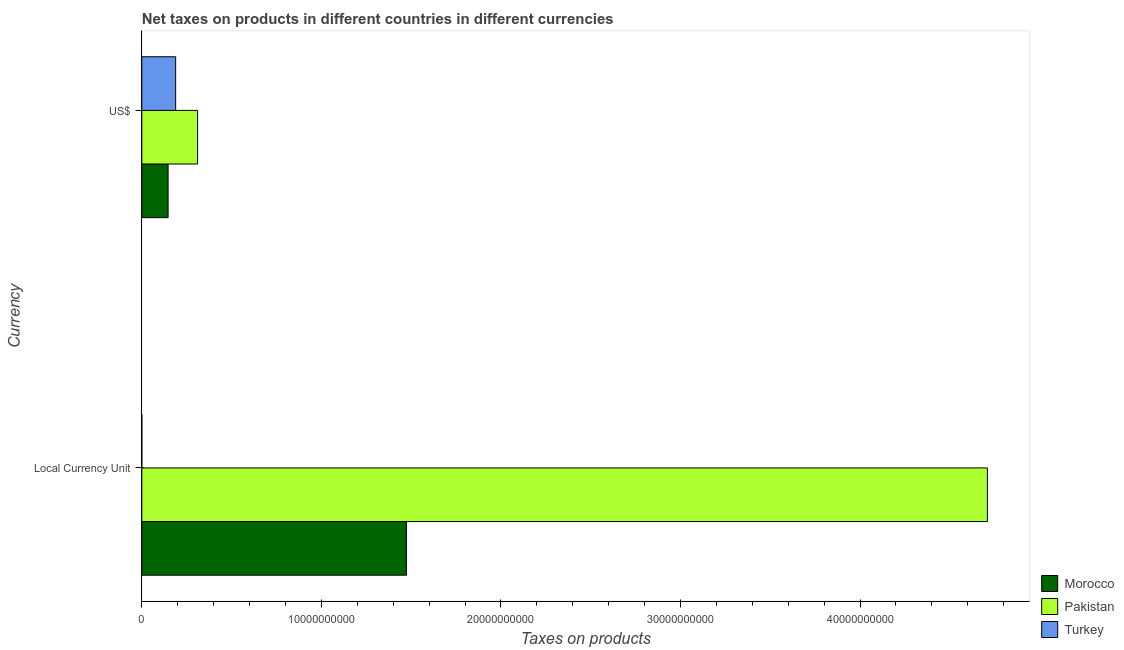How many different coloured bars are there?
Your answer should be compact. 3. How many groups of bars are there?
Make the answer very short. 2. Are the number of bars per tick equal to the number of legend labels?
Your answer should be compact. Yes. Are the number of bars on each tick of the Y-axis equal?
Keep it short and to the point. Yes. What is the label of the 2nd group of bars from the top?
Offer a terse response. Local Currency Unit. What is the net taxes in constant 2005 us$ in Pakistan?
Provide a short and direct response. 4.71e+1. Across all countries, what is the maximum net taxes in us$?
Give a very brief answer. 3.11e+09. Across all countries, what is the minimum net taxes in constant 2005 us$?
Offer a terse response. 9.84e+05. In which country was the net taxes in us$ maximum?
Your answer should be compact. Pakistan. In which country was the net taxes in us$ minimum?
Offer a very short reply. Morocco. What is the total net taxes in constant 2005 us$ in the graph?
Provide a succinct answer. 6.18e+1. What is the difference between the net taxes in us$ in Morocco and that in Pakistan?
Keep it short and to the point. -1.64e+09. What is the difference between the net taxes in us$ in Turkey and the net taxes in constant 2005 us$ in Pakistan?
Offer a terse response. -4.52e+1. What is the average net taxes in constant 2005 us$ per country?
Your answer should be very brief. 2.06e+1. What is the difference between the net taxes in us$ and net taxes in constant 2005 us$ in Morocco?
Your answer should be very brief. -1.33e+1. In how many countries, is the net taxes in constant 2005 us$ greater than 14000000000 units?
Make the answer very short. 2. What is the ratio of the net taxes in us$ in Turkey to that in Pakistan?
Provide a short and direct response. 0.61. Is the net taxes in constant 2005 us$ in Turkey less than that in Morocco?
Provide a succinct answer. Yes. In how many countries, is the net taxes in constant 2005 us$ greater than the average net taxes in constant 2005 us$ taken over all countries?
Your answer should be very brief. 1. What does the 3rd bar from the top in Local Currency Unit represents?
Your response must be concise. Morocco. How many countries are there in the graph?
Your answer should be very brief. 3. Are the values on the major ticks of X-axis written in scientific E-notation?
Your response must be concise. No. Does the graph contain grids?
Keep it short and to the point. No. Where does the legend appear in the graph?
Ensure brevity in your answer.  Bottom right. How are the legend labels stacked?
Offer a terse response. Vertical. What is the title of the graph?
Give a very brief answer. Net taxes on products in different countries in different currencies. Does "Honduras" appear as one of the legend labels in the graph?
Keep it short and to the point. No. What is the label or title of the X-axis?
Keep it short and to the point. Taxes on products. What is the label or title of the Y-axis?
Keep it short and to the point. Currency. What is the Taxes on products in Morocco in Local Currency Unit?
Keep it short and to the point. 1.47e+1. What is the Taxes on products of Pakistan in Local Currency Unit?
Offer a very short reply. 4.71e+1. What is the Taxes on products in Turkey in Local Currency Unit?
Your response must be concise. 9.84e+05. What is the Taxes on products of Morocco in US$?
Ensure brevity in your answer.  1.46e+09. What is the Taxes on products in Pakistan in US$?
Give a very brief answer. 3.11e+09. What is the Taxes on products in Turkey in US$?
Ensure brevity in your answer.  1.89e+09. Across all Currency, what is the maximum Taxes on products of Morocco?
Your answer should be very brief. 1.47e+1. Across all Currency, what is the maximum Taxes on products in Pakistan?
Keep it short and to the point. 4.71e+1. Across all Currency, what is the maximum Taxes on products of Turkey?
Make the answer very short. 1.89e+09. Across all Currency, what is the minimum Taxes on products in Morocco?
Ensure brevity in your answer.  1.46e+09. Across all Currency, what is the minimum Taxes on products of Pakistan?
Keep it short and to the point. 3.11e+09. Across all Currency, what is the minimum Taxes on products in Turkey?
Give a very brief answer. 9.84e+05. What is the total Taxes on products in Morocco in the graph?
Offer a very short reply. 1.62e+1. What is the total Taxes on products of Pakistan in the graph?
Your answer should be compact. 5.02e+1. What is the total Taxes on products in Turkey in the graph?
Provide a succinct answer. 1.89e+09. What is the difference between the Taxes on products in Morocco in Local Currency Unit and that in US$?
Provide a short and direct response. 1.33e+1. What is the difference between the Taxes on products in Pakistan in Local Currency Unit and that in US$?
Keep it short and to the point. 4.40e+1. What is the difference between the Taxes on products of Turkey in Local Currency Unit and that in US$?
Your answer should be very brief. -1.88e+09. What is the difference between the Taxes on products in Morocco in Local Currency Unit and the Taxes on products in Pakistan in US$?
Your answer should be compact. 1.16e+1. What is the difference between the Taxes on products in Morocco in Local Currency Unit and the Taxes on products in Turkey in US$?
Provide a succinct answer. 1.29e+1. What is the difference between the Taxes on products of Pakistan in Local Currency Unit and the Taxes on products of Turkey in US$?
Your answer should be compact. 4.52e+1. What is the average Taxes on products of Morocco per Currency?
Your answer should be compact. 8.10e+09. What is the average Taxes on products in Pakistan per Currency?
Ensure brevity in your answer.  2.51e+1. What is the average Taxes on products of Turkey per Currency?
Give a very brief answer. 9.43e+08. What is the difference between the Taxes on products in Morocco and Taxes on products in Pakistan in Local Currency Unit?
Offer a terse response. -3.24e+1. What is the difference between the Taxes on products in Morocco and Taxes on products in Turkey in Local Currency Unit?
Keep it short and to the point. 1.47e+1. What is the difference between the Taxes on products of Pakistan and Taxes on products of Turkey in Local Currency Unit?
Keep it short and to the point. 4.71e+1. What is the difference between the Taxes on products of Morocco and Taxes on products of Pakistan in US$?
Offer a terse response. -1.64e+09. What is the difference between the Taxes on products of Morocco and Taxes on products of Turkey in US$?
Your answer should be very brief. -4.22e+08. What is the difference between the Taxes on products of Pakistan and Taxes on products of Turkey in US$?
Your answer should be very brief. 1.22e+09. What is the ratio of the Taxes on products in Morocco in Local Currency Unit to that in US$?
Give a very brief answer. 10.06. What is the ratio of the Taxes on products of Pakistan in Local Currency Unit to that in US$?
Your answer should be very brief. 15.16. What is the ratio of the Taxes on products in Turkey in Local Currency Unit to that in US$?
Provide a short and direct response. 0. What is the difference between the highest and the second highest Taxes on products in Morocco?
Provide a short and direct response. 1.33e+1. What is the difference between the highest and the second highest Taxes on products in Pakistan?
Provide a succinct answer. 4.40e+1. What is the difference between the highest and the second highest Taxes on products of Turkey?
Ensure brevity in your answer.  1.88e+09. What is the difference between the highest and the lowest Taxes on products in Morocco?
Your response must be concise. 1.33e+1. What is the difference between the highest and the lowest Taxes on products in Pakistan?
Provide a short and direct response. 4.40e+1. What is the difference between the highest and the lowest Taxes on products in Turkey?
Your answer should be compact. 1.88e+09. 